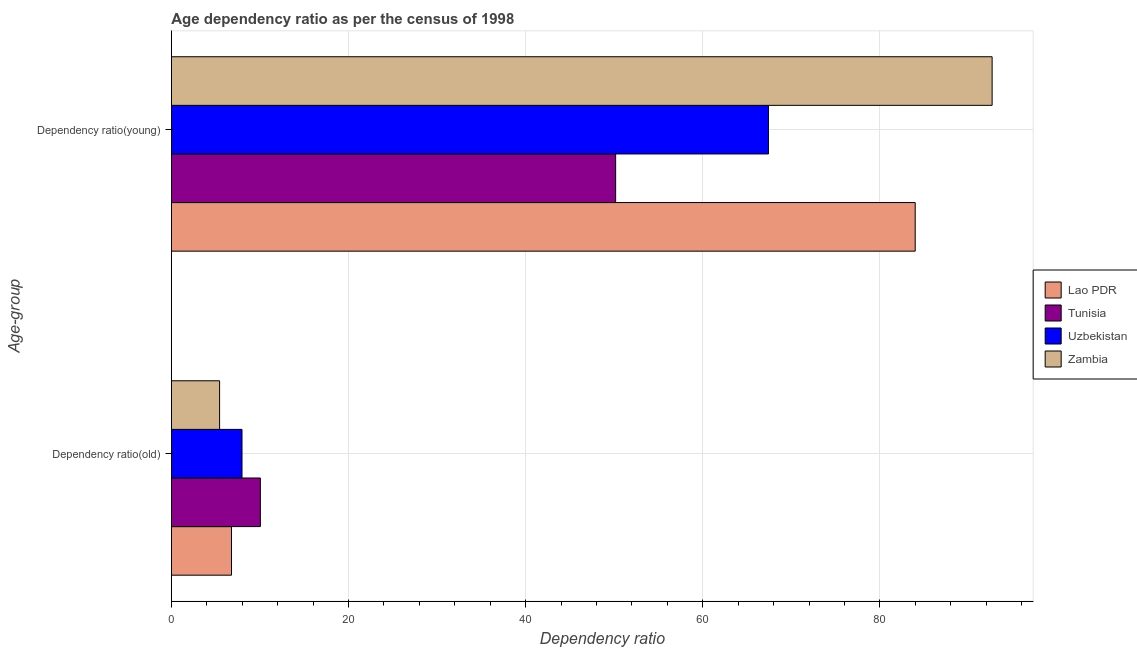How many groups of bars are there?
Make the answer very short. 2. Are the number of bars per tick equal to the number of legend labels?
Your answer should be compact. Yes. How many bars are there on the 2nd tick from the top?
Keep it short and to the point. 4. What is the label of the 1st group of bars from the top?
Your answer should be compact. Dependency ratio(young). What is the age dependency ratio(young) in Zambia?
Make the answer very short. 92.66. Across all countries, what is the maximum age dependency ratio(young)?
Give a very brief answer. 92.66. Across all countries, what is the minimum age dependency ratio(old)?
Your answer should be very brief. 5.44. In which country was the age dependency ratio(young) maximum?
Offer a terse response. Zambia. In which country was the age dependency ratio(old) minimum?
Your response must be concise. Zambia. What is the total age dependency ratio(old) in the graph?
Make the answer very short. 30.25. What is the difference between the age dependency ratio(young) in Zambia and that in Lao PDR?
Keep it short and to the point. 8.68. What is the difference between the age dependency ratio(old) in Zambia and the age dependency ratio(young) in Tunisia?
Ensure brevity in your answer.  -44.71. What is the average age dependency ratio(old) per country?
Provide a short and direct response. 7.56. What is the difference between the age dependency ratio(old) and age dependency ratio(young) in Zambia?
Your answer should be compact. -87.22. What is the ratio of the age dependency ratio(young) in Zambia to that in Tunisia?
Provide a short and direct response. 1.85. In how many countries, is the age dependency ratio(old) greater than the average age dependency ratio(old) taken over all countries?
Your response must be concise. 2. What does the 4th bar from the top in Dependency ratio(old) represents?
Ensure brevity in your answer.  Lao PDR. What does the 3rd bar from the bottom in Dependency ratio(young) represents?
Make the answer very short. Uzbekistan. How many bars are there?
Your response must be concise. 8. How many countries are there in the graph?
Provide a succinct answer. 4. What is the difference between two consecutive major ticks on the X-axis?
Offer a terse response. 20. Does the graph contain any zero values?
Your response must be concise. No. What is the title of the graph?
Keep it short and to the point. Age dependency ratio as per the census of 1998. Does "Euro area" appear as one of the legend labels in the graph?
Ensure brevity in your answer.  No. What is the label or title of the X-axis?
Give a very brief answer. Dependency ratio. What is the label or title of the Y-axis?
Your answer should be compact. Age-group. What is the Dependency ratio in Lao PDR in Dependency ratio(old)?
Ensure brevity in your answer.  6.79. What is the Dependency ratio in Tunisia in Dependency ratio(old)?
Give a very brief answer. 10.05. What is the Dependency ratio of Uzbekistan in Dependency ratio(old)?
Ensure brevity in your answer.  7.97. What is the Dependency ratio in Zambia in Dependency ratio(old)?
Provide a short and direct response. 5.44. What is the Dependency ratio in Lao PDR in Dependency ratio(young)?
Ensure brevity in your answer.  83.98. What is the Dependency ratio of Tunisia in Dependency ratio(young)?
Offer a terse response. 50.16. What is the Dependency ratio of Uzbekistan in Dependency ratio(young)?
Provide a succinct answer. 67.41. What is the Dependency ratio in Zambia in Dependency ratio(young)?
Your answer should be very brief. 92.66. Across all Age-group, what is the maximum Dependency ratio of Lao PDR?
Provide a succinct answer. 83.98. Across all Age-group, what is the maximum Dependency ratio in Tunisia?
Your response must be concise. 50.16. Across all Age-group, what is the maximum Dependency ratio of Uzbekistan?
Give a very brief answer. 67.41. Across all Age-group, what is the maximum Dependency ratio in Zambia?
Offer a very short reply. 92.66. Across all Age-group, what is the minimum Dependency ratio of Lao PDR?
Your answer should be compact. 6.79. Across all Age-group, what is the minimum Dependency ratio in Tunisia?
Keep it short and to the point. 10.05. Across all Age-group, what is the minimum Dependency ratio of Uzbekistan?
Provide a succinct answer. 7.97. Across all Age-group, what is the minimum Dependency ratio of Zambia?
Your answer should be very brief. 5.44. What is the total Dependency ratio of Lao PDR in the graph?
Your answer should be compact. 90.76. What is the total Dependency ratio of Tunisia in the graph?
Provide a short and direct response. 60.2. What is the total Dependency ratio in Uzbekistan in the graph?
Your answer should be very brief. 75.38. What is the total Dependency ratio of Zambia in the graph?
Your answer should be very brief. 98.1. What is the difference between the Dependency ratio of Lao PDR in Dependency ratio(old) and that in Dependency ratio(young)?
Your response must be concise. -77.19. What is the difference between the Dependency ratio in Tunisia in Dependency ratio(old) and that in Dependency ratio(young)?
Ensure brevity in your answer.  -40.11. What is the difference between the Dependency ratio in Uzbekistan in Dependency ratio(old) and that in Dependency ratio(young)?
Provide a short and direct response. -59.44. What is the difference between the Dependency ratio in Zambia in Dependency ratio(old) and that in Dependency ratio(young)?
Offer a terse response. -87.22. What is the difference between the Dependency ratio of Lao PDR in Dependency ratio(old) and the Dependency ratio of Tunisia in Dependency ratio(young)?
Keep it short and to the point. -43.37. What is the difference between the Dependency ratio in Lao PDR in Dependency ratio(old) and the Dependency ratio in Uzbekistan in Dependency ratio(young)?
Your answer should be compact. -60.62. What is the difference between the Dependency ratio in Lao PDR in Dependency ratio(old) and the Dependency ratio in Zambia in Dependency ratio(young)?
Your answer should be compact. -85.87. What is the difference between the Dependency ratio of Tunisia in Dependency ratio(old) and the Dependency ratio of Uzbekistan in Dependency ratio(young)?
Provide a short and direct response. -57.37. What is the difference between the Dependency ratio of Tunisia in Dependency ratio(old) and the Dependency ratio of Zambia in Dependency ratio(young)?
Offer a terse response. -82.62. What is the difference between the Dependency ratio of Uzbekistan in Dependency ratio(old) and the Dependency ratio of Zambia in Dependency ratio(young)?
Give a very brief answer. -84.69. What is the average Dependency ratio in Lao PDR per Age-group?
Keep it short and to the point. 45.38. What is the average Dependency ratio of Tunisia per Age-group?
Provide a succinct answer. 30.1. What is the average Dependency ratio in Uzbekistan per Age-group?
Give a very brief answer. 37.69. What is the average Dependency ratio in Zambia per Age-group?
Provide a succinct answer. 49.05. What is the difference between the Dependency ratio of Lao PDR and Dependency ratio of Tunisia in Dependency ratio(old)?
Make the answer very short. -3.26. What is the difference between the Dependency ratio in Lao PDR and Dependency ratio in Uzbekistan in Dependency ratio(old)?
Keep it short and to the point. -1.19. What is the difference between the Dependency ratio in Lao PDR and Dependency ratio in Zambia in Dependency ratio(old)?
Offer a terse response. 1.34. What is the difference between the Dependency ratio of Tunisia and Dependency ratio of Uzbekistan in Dependency ratio(old)?
Your answer should be very brief. 2.07. What is the difference between the Dependency ratio in Tunisia and Dependency ratio in Zambia in Dependency ratio(old)?
Offer a very short reply. 4.6. What is the difference between the Dependency ratio in Uzbekistan and Dependency ratio in Zambia in Dependency ratio(old)?
Provide a succinct answer. 2.53. What is the difference between the Dependency ratio in Lao PDR and Dependency ratio in Tunisia in Dependency ratio(young)?
Your response must be concise. 33.82. What is the difference between the Dependency ratio of Lao PDR and Dependency ratio of Uzbekistan in Dependency ratio(young)?
Make the answer very short. 16.56. What is the difference between the Dependency ratio in Lao PDR and Dependency ratio in Zambia in Dependency ratio(young)?
Make the answer very short. -8.68. What is the difference between the Dependency ratio of Tunisia and Dependency ratio of Uzbekistan in Dependency ratio(young)?
Provide a short and direct response. -17.25. What is the difference between the Dependency ratio of Tunisia and Dependency ratio of Zambia in Dependency ratio(young)?
Your answer should be very brief. -42.5. What is the difference between the Dependency ratio in Uzbekistan and Dependency ratio in Zambia in Dependency ratio(young)?
Your answer should be compact. -25.25. What is the ratio of the Dependency ratio in Lao PDR in Dependency ratio(old) to that in Dependency ratio(young)?
Ensure brevity in your answer.  0.08. What is the ratio of the Dependency ratio in Tunisia in Dependency ratio(old) to that in Dependency ratio(young)?
Provide a succinct answer. 0.2. What is the ratio of the Dependency ratio in Uzbekistan in Dependency ratio(old) to that in Dependency ratio(young)?
Offer a very short reply. 0.12. What is the ratio of the Dependency ratio in Zambia in Dependency ratio(old) to that in Dependency ratio(young)?
Keep it short and to the point. 0.06. What is the difference between the highest and the second highest Dependency ratio of Lao PDR?
Offer a terse response. 77.19. What is the difference between the highest and the second highest Dependency ratio in Tunisia?
Your answer should be very brief. 40.11. What is the difference between the highest and the second highest Dependency ratio of Uzbekistan?
Offer a terse response. 59.44. What is the difference between the highest and the second highest Dependency ratio of Zambia?
Provide a short and direct response. 87.22. What is the difference between the highest and the lowest Dependency ratio of Lao PDR?
Your answer should be very brief. 77.19. What is the difference between the highest and the lowest Dependency ratio in Tunisia?
Provide a short and direct response. 40.11. What is the difference between the highest and the lowest Dependency ratio of Uzbekistan?
Your answer should be very brief. 59.44. What is the difference between the highest and the lowest Dependency ratio of Zambia?
Your response must be concise. 87.22. 